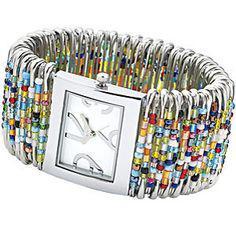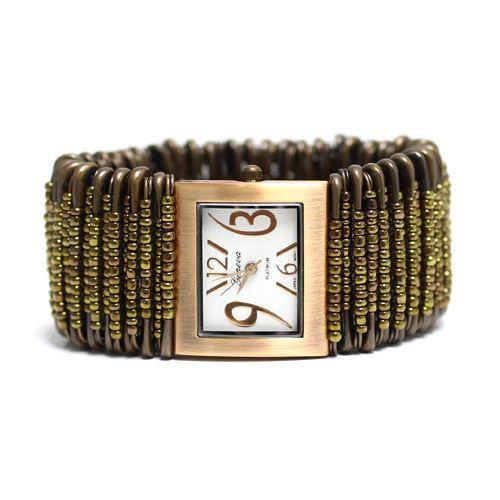The first image is the image on the left, the second image is the image on the right. Considering the images on both sides, is "Each image contains one bracelet constructed of rows of vertical beaded safety pins, and no bracelet has a watch face." valid? Answer yes or no. No. The first image is the image on the left, the second image is the image on the right. For the images shown, is this caption "In the left image, all beads are tans, blacks, whites and oranges." true? Answer yes or no. No. 